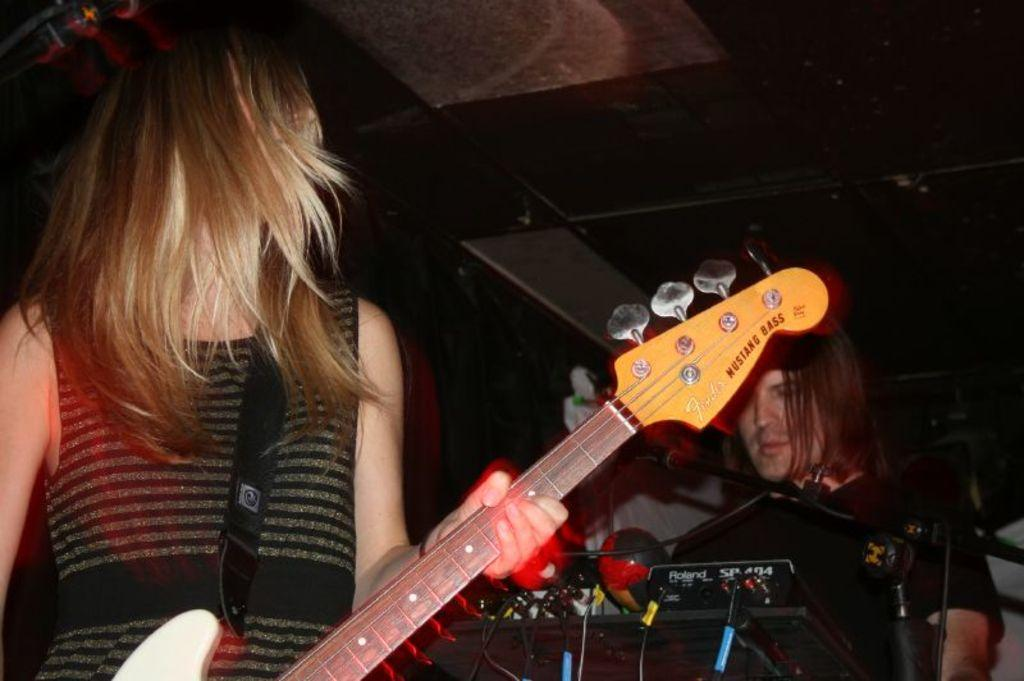What is the woman in the image doing? The woman is playing a guitar. Can you describe the position of the man in the image? The man is standing behind the woman. What type of cheese is the woman using to play the guitar in the image? There is no cheese present in the image, and the woman is playing a guitar, not a cheese. Can you see any twigs or iron objects in the image? There is no mention of twigs or iron objects in the image; it features a woman playing a guitar and a man standing behind her. 